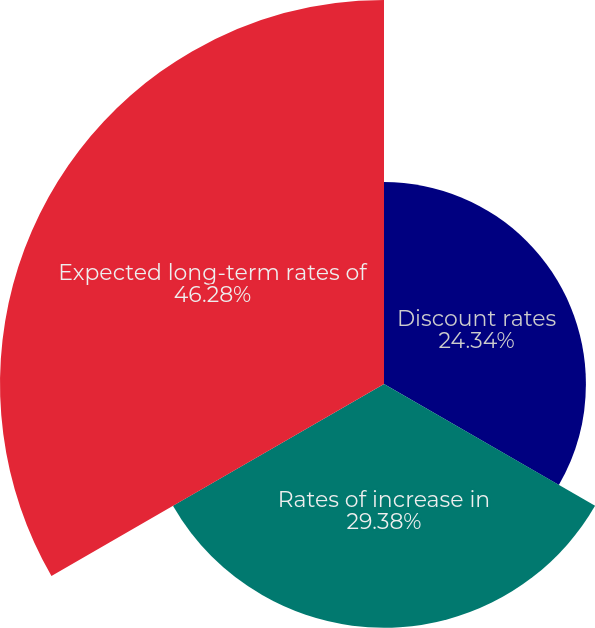<chart> <loc_0><loc_0><loc_500><loc_500><pie_chart><fcel>Discount rates<fcel>Rates of increase in<fcel>Expected long-term rates of<nl><fcel>24.34%<fcel>29.38%<fcel>46.29%<nl></chart> 